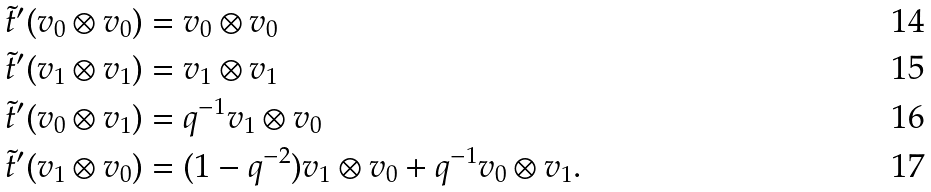Convert formula to latex. <formula><loc_0><loc_0><loc_500><loc_500>\tilde { t } ^ { \prime } ( v _ { 0 } \otimes v _ { 0 } ) & = v _ { 0 } \otimes v _ { 0 } \\ \tilde { t } ^ { \prime } ( v _ { 1 } \otimes v _ { 1 } ) & = v _ { 1 } \otimes v _ { 1 } \\ \tilde { t } ^ { \prime } ( v _ { 0 } \otimes v _ { 1 } ) & = q ^ { - 1 } v _ { 1 } \otimes v _ { 0 } \\ \tilde { t } ^ { \prime } ( v _ { 1 } \otimes v _ { 0 } ) & = ( 1 - q ^ { - 2 } ) v _ { 1 } \otimes v _ { 0 } + q ^ { - 1 } v _ { 0 } \otimes v _ { 1 } .</formula> 